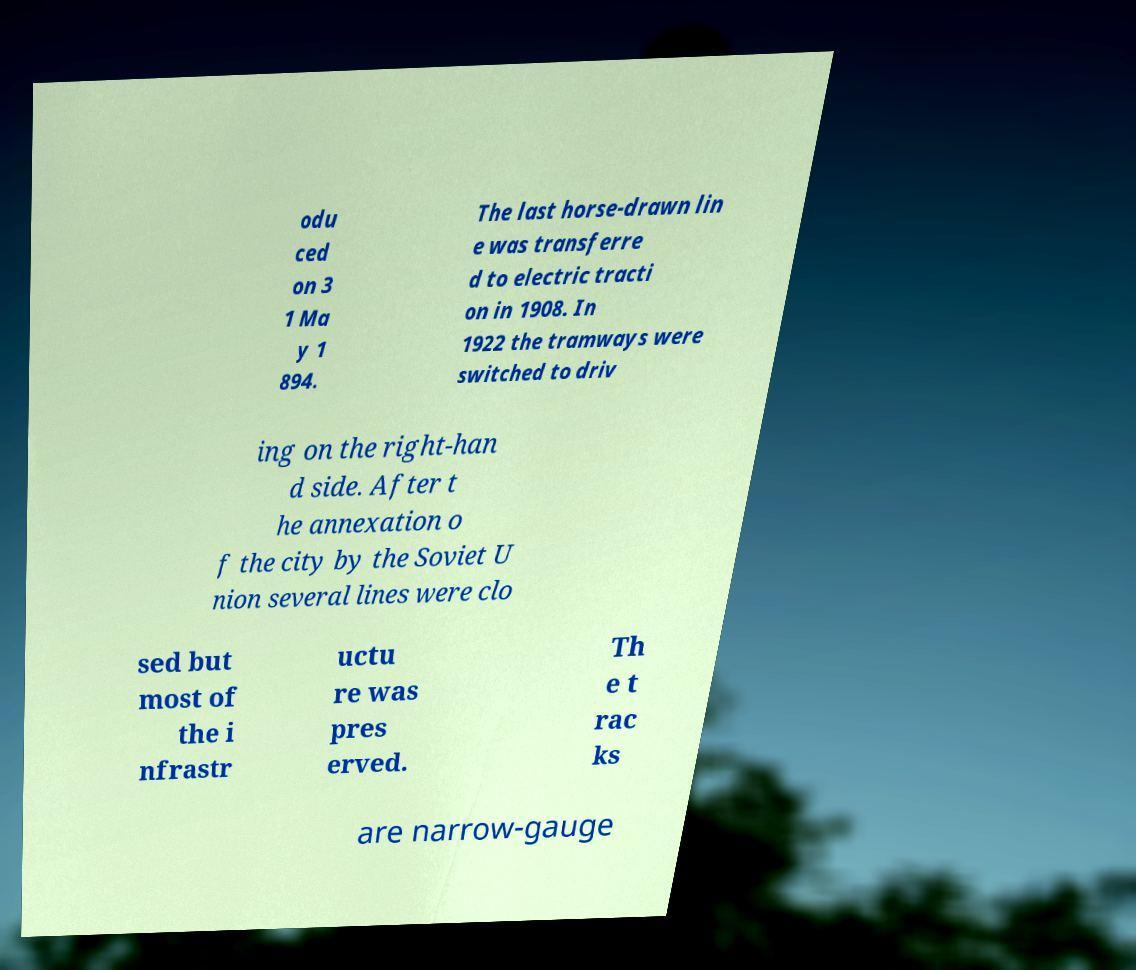There's text embedded in this image that I need extracted. Can you transcribe it verbatim? odu ced on 3 1 Ma y 1 894. The last horse-drawn lin e was transferre d to electric tracti on in 1908. In 1922 the tramways were switched to driv ing on the right-han d side. After t he annexation o f the city by the Soviet U nion several lines were clo sed but most of the i nfrastr uctu re was pres erved. Th e t rac ks are narrow-gauge 